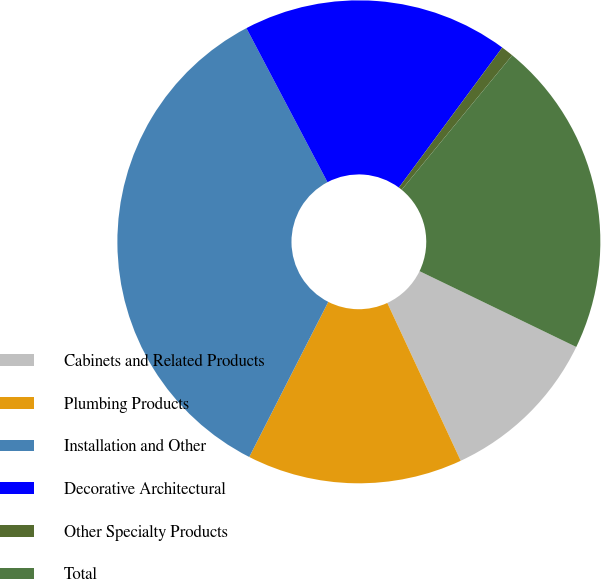Convert chart to OTSL. <chart><loc_0><loc_0><loc_500><loc_500><pie_chart><fcel>Cabinets and Related Products<fcel>Plumbing Products<fcel>Installation and Other<fcel>Decorative Architectural<fcel>Other Specialty Products<fcel>Total<nl><fcel>10.9%<fcel>14.43%<fcel>34.79%<fcel>17.83%<fcel>0.83%<fcel>21.22%<nl></chart> 